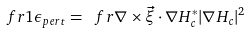<formula> <loc_0><loc_0><loc_500><loc_500>\ f r { 1 } { \epsilon _ { p e r t } } = \ f r { \nabla \times \vec { \xi } \cdot \nabla H _ { c } ^ { * } } { | \nabla H _ { c } | ^ { 2 } }</formula> 